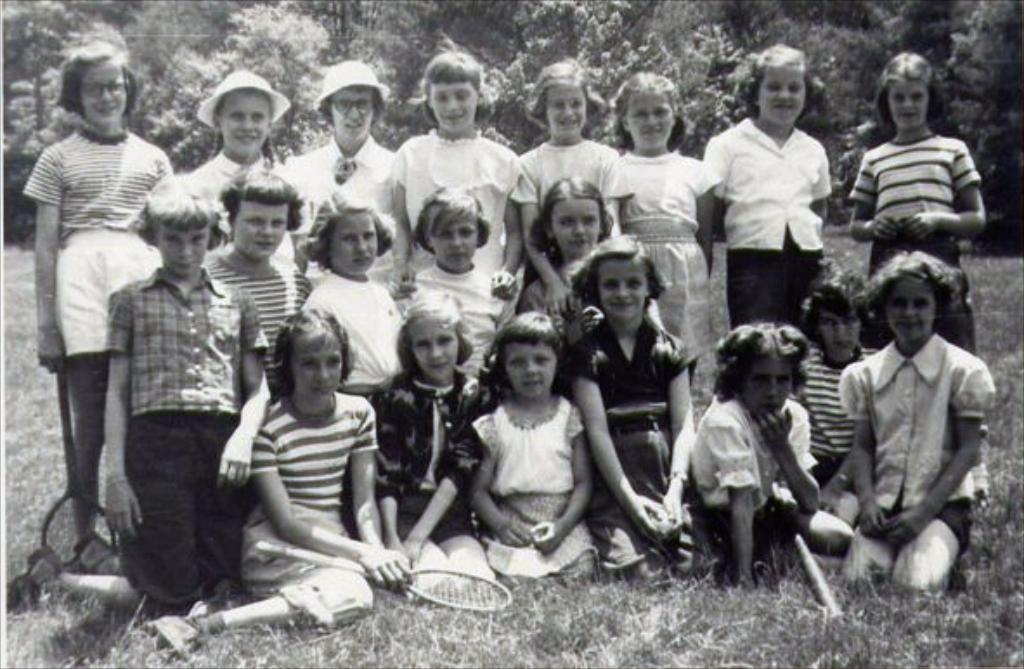What is the color scheme of the image? The image is black and white. What can be seen on the ground in the image? There are children on the ground in the image. What type of surface is the ground covered with? The ground is covered with grass. What is visible in the background of the image? There are trees in the background of the image. What type of insurance is being discussed by the children in the image? There is no discussion of insurance in the image; it features children on the ground with grass and trees in the background. 